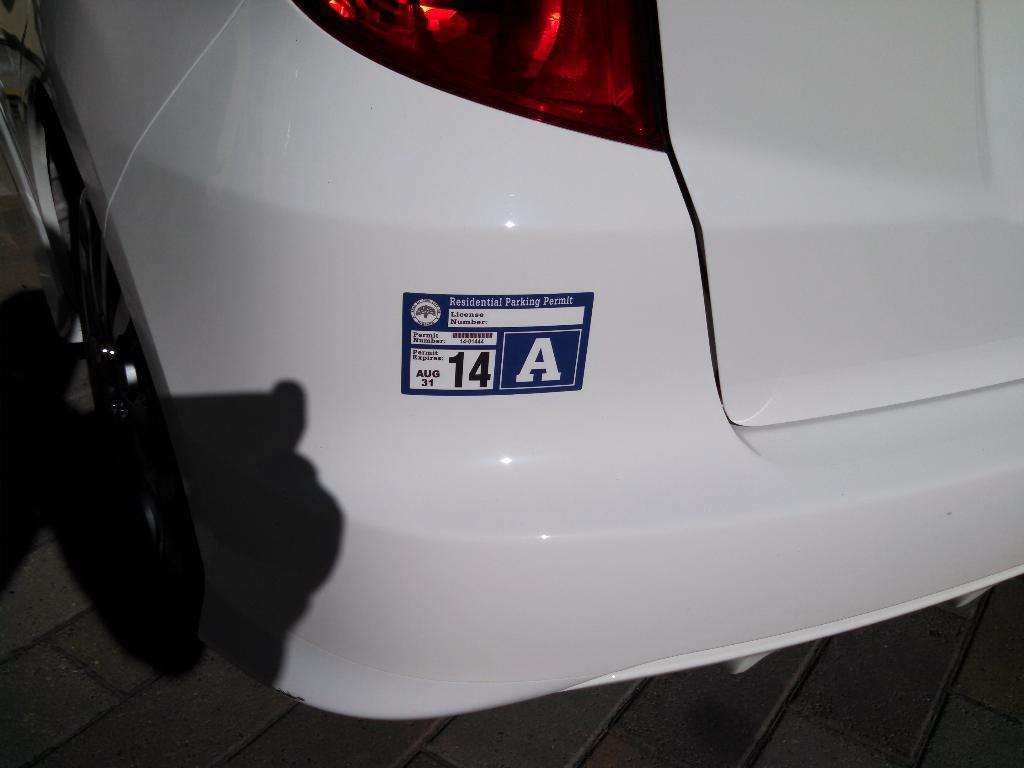What is the main subject of the image? The main subject of the image is a car. How is the car's back side view depicted in the image? The car has a truncated back side view in the image. Where is the car located in the image? The car is on the ground in the image. What can be seen below the car in the image? The car's shadow is visible in the image. What type of cemetery can be seen in the background of the image? There is no cemetery present in the image; it features a car with a truncated back side view. How many planes are flying above the car in the image? There are no planes visible in the image; it only shows a car on the ground with its shadow. 